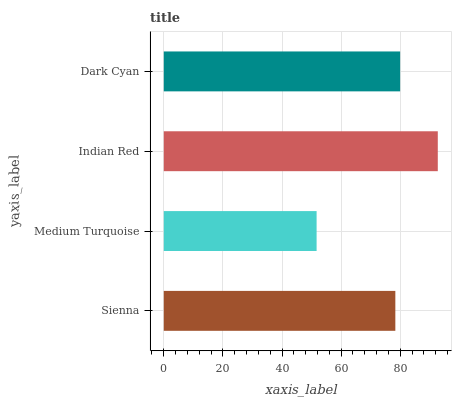Is Medium Turquoise the minimum?
Answer yes or no. Yes. Is Indian Red the maximum?
Answer yes or no. Yes. Is Indian Red the minimum?
Answer yes or no. No. Is Medium Turquoise the maximum?
Answer yes or no. No. Is Indian Red greater than Medium Turquoise?
Answer yes or no. Yes. Is Medium Turquoise less than Indian Red?
Answer yes or no. Yes. Is Medium Turquoise greater than Indian Red?
Answer yes or no. No. Is Indian Red less than Medium Turquoise?
Answer yes or no. No. Is Dark Cyan the high median?
Answer yes or no. Yes. Is Sienna the low median?
Answer yes or no. Yes. Is Indian Red the high median?
Answer yes or no. No. Is Indian Red the low median?
Answer yes or no. No. 